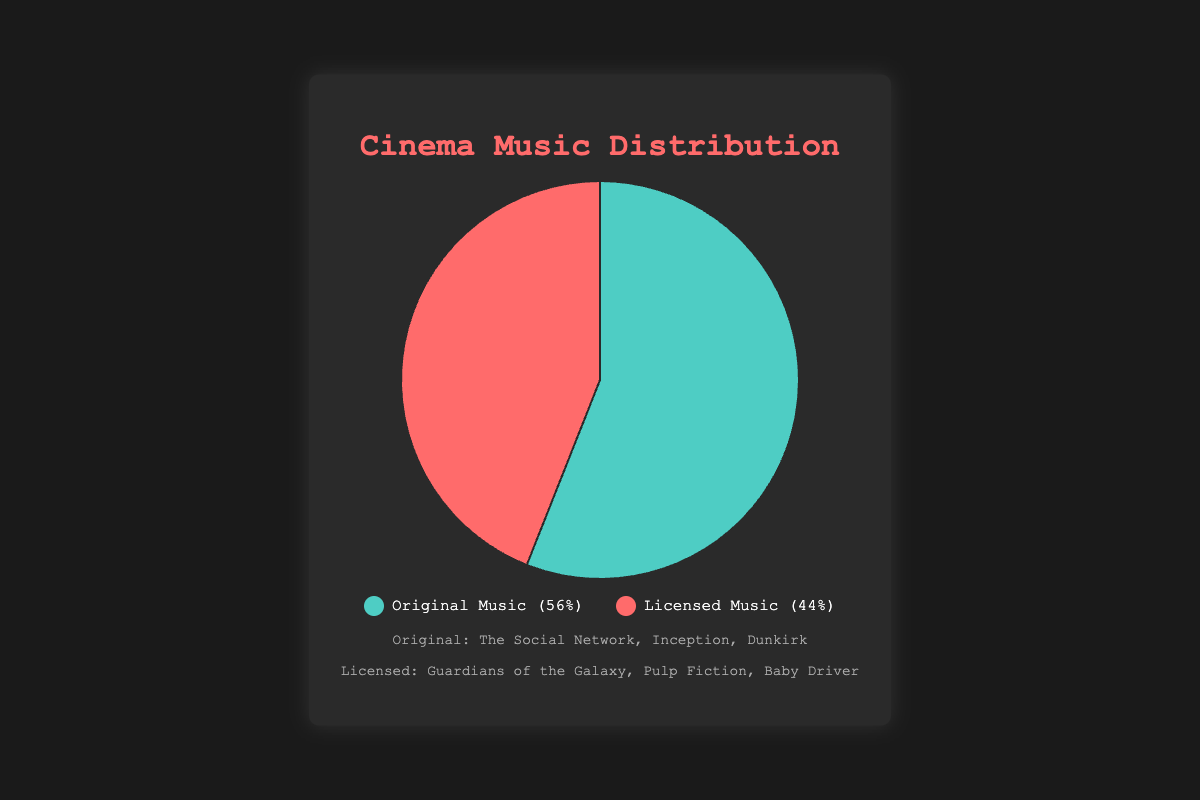What's the percentage of films with original music? The chart shows two segments with one indicating the percentage of films with original music. The legend specifies that the segment for "Original Music" is 56%.
Answer: 56% What's the percentage difference between films with original music and licensed music? The percentages for original and licensed music are 56% and 44%, respectively. The difference is calculated as 56% - 44% = 12%.
Answer: 12% Which category has more films, original music or licensed music? From the chart, the segment for "Original Music" represents 56%, while "Licensed Music" represents 44%. 56% is greater than 44%.
Answer: Original Music What are some examples of films with licensed music? The figure's example section lists movies falling under both categories. For Licensed Music, it mentions "Guardians of the Galaxy", "Pulp Fiction", and "Baby Driver".
Answer: Guardians of the Galaxy, Pulp Fiction, Baby Driver What's the total percentage represented in the chart? Pie charts represent a whole, which is 100%. The combined percentages of Original Music (56%) and Licensed Music (44%) add up to 100%.
Answer: 100% If there are 1000 films analyzed, how many films use licensed music? The percentage of films with licensed music is 44%. To find the number of films with licensed music out of 1000, calculate 44% of 1000, which is 0.44 * 1000 = 440.
Answer: 440 What color represents films with licensed music in the chart? The legend in the chart shows that "Licensed Music" is represented by the red color.
Answer: Red Are there more films with original music than licensed music? Comparing the percentages, Original Music has 56% while Licensed Music has 44%. Since 56% is greater than 44%, there are more films with Original Music.
Answer: Yes What are the colors used in the chart to represent each category? The legend in the chart specifies that "Original Music" is represented by green, and "Licensed Music" is represented by red.
Answer: Green and Red What is the dominant type of music in the analyzed films? The pie chart has a larger segment for "Original Music" (56%) compared to "Licensed Music" (44%), making original music the dominant type.
Answer: Original Music 